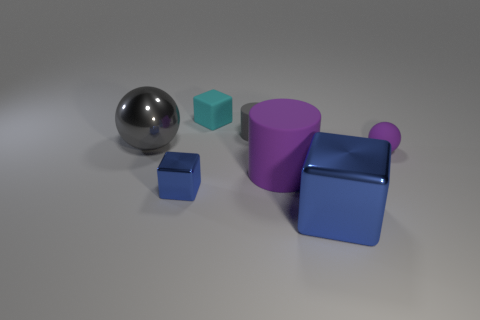What material do the objects appear to be made of, and which one stands out? The objects seem to be made of a matte plastic or rubber material, except for the sphere, which has a reflective metallic finish. The sphere stands out not only because of its reflective property but also due to its distinct spherical shape among the other cubic and cylindrical items. 